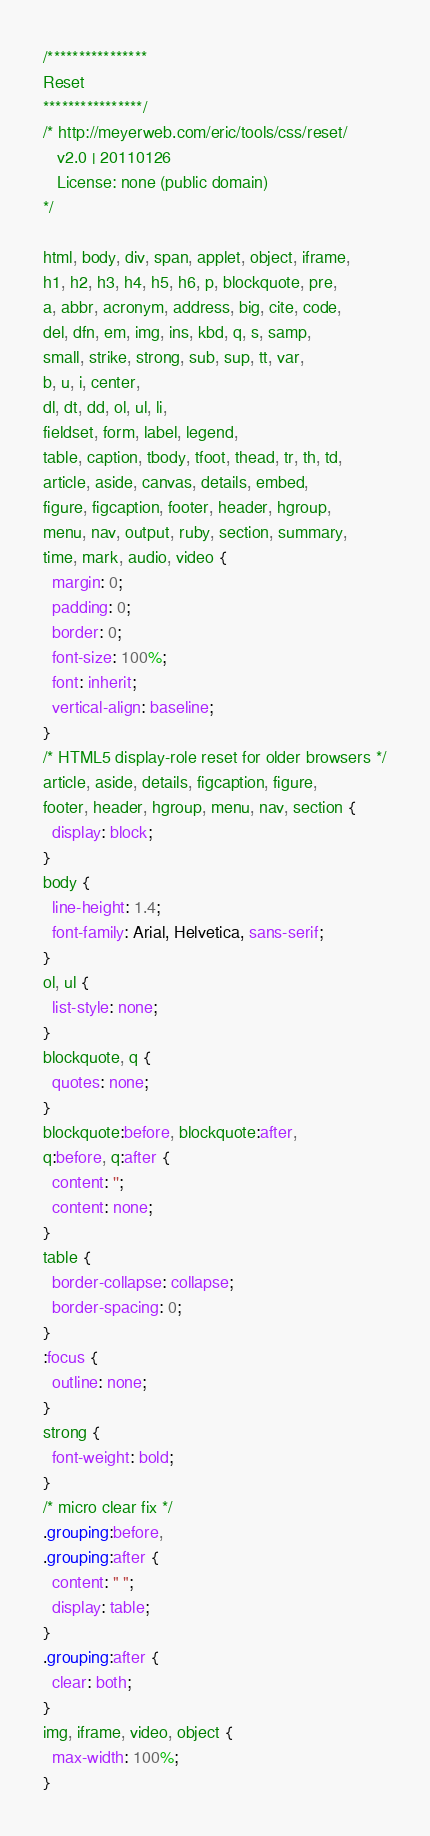Convert code to text. <code><loc_0><loc_0><loc_500><loc_500><_CSS_>/****************
Reset
****************/
/* http://meyerweb.com/eric/tools/css/reset/ 
   v2.0 | 20110126
   License: none (public domain)
*/

html, body, div, span, applet, object, iframe,
h1, h2, h3, h4, h5, h6, p, blockquote, pre,
a, abbr, acronym, address, big, cite, code,
del, dfn, em, img, ins, kbd, q, s, samp,
small, strike, strong, sub, sup, tt, var,
b, u, i, center,
dl, dt, dd, ol, ul, li,
fieldset, form, label, legend,
table, caption, tbody, tfoot, thead, tr, th, td,
article, aside, canvas, details, embed, 
figure, figcaption, footer, header, hgroup, 
menu, nav, output, ruby, section, summary,
time, mark, audio, video {
  margin: 0;
  padding: 0;
  border: 0;
  font-size: 100%;
  font: inherit;
  vertical-align: baseline;
}
/* HTML5 display-role reset for older browsers */
article, aside, details, figcaption, figure, 
footer, header, hgroup, menu, nav, section {
  display: block;
}
body {
  line-height: 1.4;
  font-family: Arial, Helvetica, sans-serif;
}
ol, ul {
  list-style: none;
}
blockquote, q {
  quotes: none;
}
blockquote:before, blockquote:after,
q:before, q:after {
  content: '';
  content: none;
}
table {
  border-collapse: collapse;
  border-spacing: 0;
}
:focus {
  outline: none;
}
strong {
  font-weight: bold; 
}
/* micro clear fix */
.grouping:before,
.grouping:after {
  content: " ";
  display: table; 
}
.grouping:after {
  clear: both; 
}
img, iframe, video, object {
  max-width: 100%; 
}</code> 